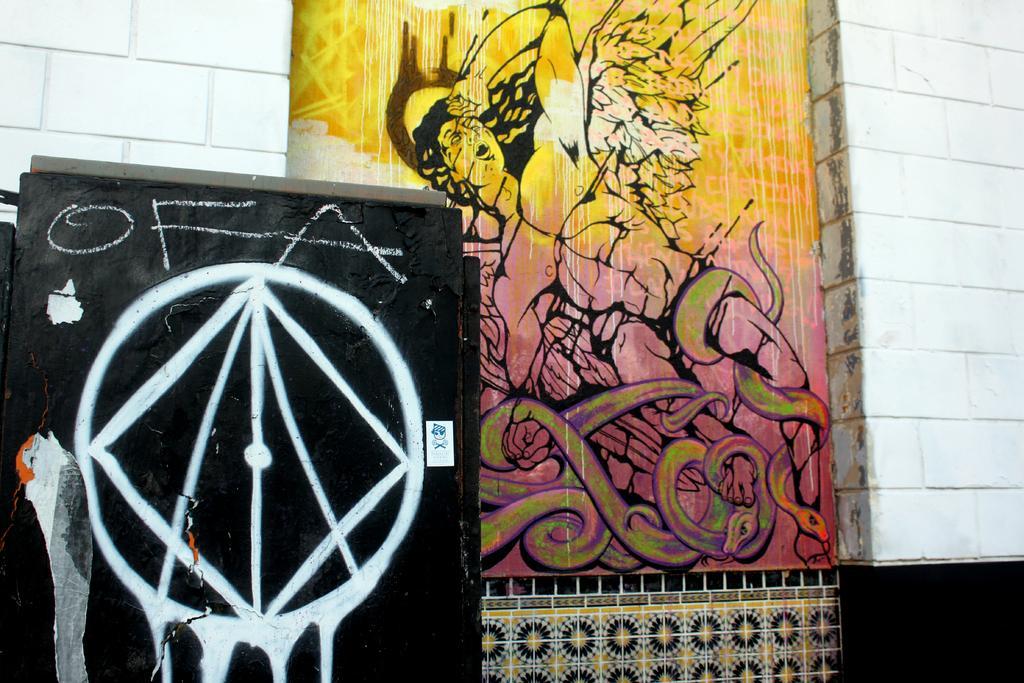Can you describe this image briefly? In this image I can observe two paintings on the wall. The wall is white in color. 